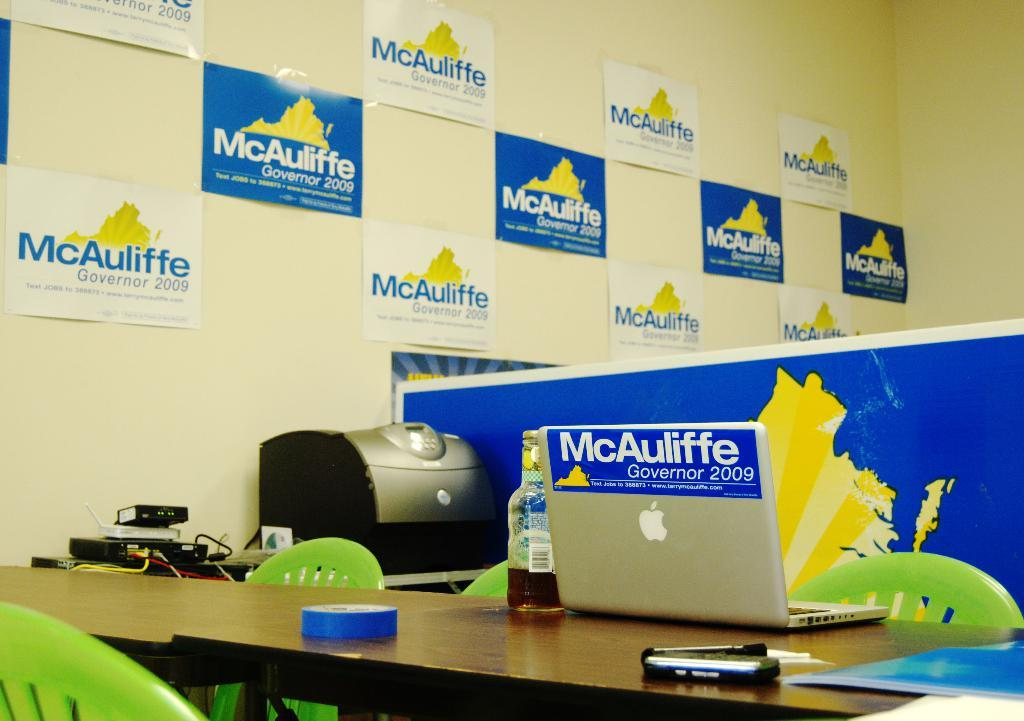<image>
Summarize the visual content of the image. 2006 governor campaign office for larry mcauliffe with bumper sticker on back of apple laptop 